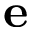Convert formula to latex. <formula><loc_0><loc_0><loc_500><loc_500>e</formula> 